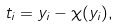Convert formula to latex. <formula><loc_0><loc_0><loc_500><loc_500>t _ { i } = y _ { i } - \chi ( y _ { i } ) ,</formula> 